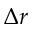<formula> <loc_0><loc_0><loc_500><loc_500>\Delta r</formula> 